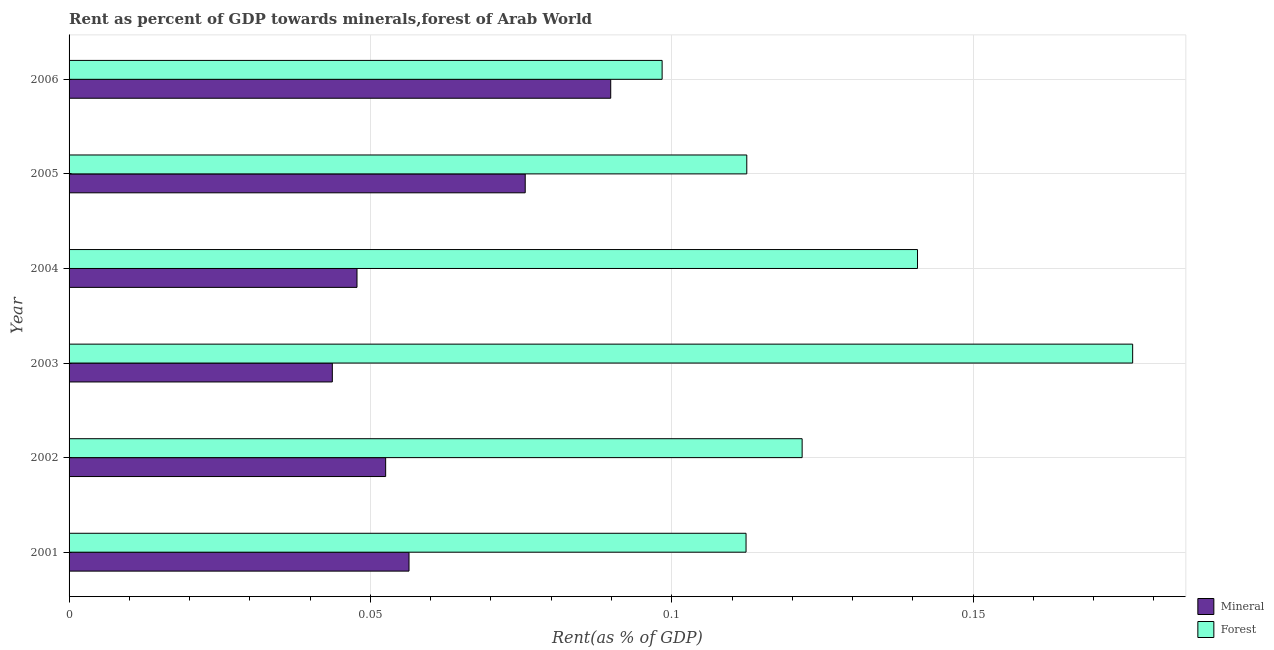How many different coloured bars are there?
Your answer should be compact. 2. Are the number of bars per tick equal to the number of legend labels?
Ensure brevity in your answer.  Yes. What is the label of the 6th group of bars from the top?
Offer a terse response. 2001. What is the forest rent in 2005?
Your response must be concise. 0.11. Across all years, what is the maximum mineral rent?
Your response must be concise. 0.09. Across all years, what is the minimum mineral rent?
Offer a very short reply. 0.04. In which year was the forest rent maximum?
Keep it short and to the point. 2003. What is the total mineral rent in the graph?
Your answer should be very brief. 0.37. What is the difference between the forest rent in 2002 and that in 2005?
Provide a succinct answer. 0.01. What is the difference between the mineral rent in 2004 and the forest rent in 2002?
Ensure brevity in your answer.  -0.07. What is the average mineral rent per year?
Keep it short and to the point. 0.06. In the year 2003, what is the difference between the mineral rent and forest rent?
Make the answer very short. -0.13. What is the ratio of the forest rent in 2001 to that in 2002?
Provide a succinct answer. 0.92. Is the difference between the mineral rent in 2001 and 2005 greater than the difference between the forest rent in 2001 and 2005?
Your response must be concise. No. What is the difference between the highest and the second highest forest rent?
Ensure brevity in your answer.  0.04. Is the sum of the forest rent in 2002 and 2005 greater than the maximum mineral rent across all years?
Ensure brevity in your answer.  Yes. What does the 2nd bar from the top in 2006 represents?
Offer a terse response. Mineral. What does the 1st bar from the bottom in 2006 represents?
Provide a succinct answer. Mineral. How many bars are there?
Your answer should be very brief. 12. Does the graph contain any zero values?
Provide a short and direct response. No. Where does the legend appear in the graph?
Your answer should be compact. Bottom right. How are the legend labels stacked?
Provide a short and direct response. Vertical. What is the title of the graph?
Ensure brevity in your answer.  Rent as percent of GDP towards minerals,forest of Arab World. Does "Frequency of shipment arrival" appear as one of the legend labels in the graph?
Keep it short and to the point. No. What is the label or title of the X-axis?
Provide a succinct answer. Rent(as % of GDP). What is the label or title of the Y-axis?
Keep it short and to the point. Year. What is the Rent(as % of GDP) in Mineral in 2001?
Provide a short and direct response. 0.06. What is the Rent(as % of GDP) in Forest in 2001?
Give a very brief answer. 0.11. What is the Rent(as % of GDP) of Mineral in 2002?
Offer a very short reply. 0.05. What is the Rent(as % of GDP) of Forest in 2002?
Offer a terse response. 0.12. What is the Rent(as % of GDP) of Mineral in 2003?
Make the answer very short. 0.04. What is the Rent(as % of GDP) in Forest in 2003?
Give a very brief answer. 0.18. What is the Rent(as % of GDP) of Mineral in 2004?
Ensure brevity in your answer.  0.05. What is the Rent(as % of GDP) of Forest in 2004?
Give a very brief answer. 0.14. What is the Rent(as % of GDP) in Mineral in 2005?
Offer a terse response. 0.08. What is the Rent(as % of GDP) in Forest in 2005?
Offer a very short reply. 0.11. What is the Rent(as % of GDP) in Mineral in 2006?
Keep it short and to the point. 0.09. What is the Rent(as % of GDP) of Forest in 2006?
Provide a short and direct response. 0.1. Across all years, what is the maximum Rent(as % of GDP) in Mineral?
Your answer should be compact. 0.09. Across all years, what is the maximum Rent(as % of GDP) of Forest?
Ensure brevity in your answer.  0.18. Across all years, what is the minimum Rent(as % of GDP) of Mineral?
Your answer should be very brief. 0.04. Across all years, what is the minimum Rent(as % of GDP) of Forest?
Make the answer very short. 0.1. What is the total Rent(as % of GDP) of Mineral in the graph?
Your response must be concise. 0.37. What is the total Rent(as % of GDP) in Forest in the graph?
Keep it short and to the point. 0.76. What is the difference between the Rent(as % of GDP) of Mineral in 2001 and that in 2002?
Make the answer very short. 0. What is the difference between the Rent(as % of GDP) of Forest in 2001 and that in 2002?
Your answer should be very brief. -0.01. What is the difference between the Rent(as % of GDP) in Mineral in 2001 and that in 2003?
Give a very brief answer. 0.01. What is the difference between the Rent(as % of GDP) in Forest in 2001 and that in 2003?
Offer a very short reply. -0.06. What is the difference between the Rent(as % of GDP) in Mineral in 2001 and that in 2004?
Give a very brief answer. 0.01. What is the difference between the Rent(as % of GDP) in Forest in 2001 and that in 2004?
Your answer should be very brief. -0.03. What is the difference between the Rent(as % of GDP) of Mineral in 2001 and that in 2005?
Provide a short and direct response. -0.02. What is the difference between the Rent(as % of GDP) in Forest in 2001 and that in 2005?
Ensure brevity in your answer.  -0. What is the difference between the Rent(as % of GDP) in Mineral in 2001 and that in 2006?
Your answer should be very brief. -0.03. What is the difference between the Rent(as % of GDP) of Forest in 2001 and that in 2006?
Your response must be concise. 0.01. What is the difference between the Rent(as % of GDP) of Mineral in 2002 and that in 2003?
Give a very brief answer. 0.01. What is the difference between the Rent(as % of GDP) in Forest in 2002 and that in 2003?
Offer a terse response. -0.05. What is the difference between the Rent(as % of GDP) in Mineral in 2002 and that in 2004?
Your answer should be compact. 0. What is the difference between the Rent(as % of GDP) in Forest in 2002 and that in 2004?
Keep it short and to the point. -0.02. What is the difference between the Rent(as % of GDP) in Mineral in 2002 and that in 2005?
Offer a terse response. -0.02. What is the difference between the Rent(as % of GDP) of Forest in 2002 and that in 2005?
Your response must be concise. 0.01. What is the difference between the Rent(as % of GDP) in Mineral in 2002 and that in 2006?
Offer a very short reply. -0.04. What is the difference between the Rent(as % of GDP) in Forest in 2002 and that in 2006?
Your answer should be compact. 0.02. What is the difference between the Rent(as % of GDP) of Mineral in 2003 and that in 2004?
Your response must be concise. -0. What is the difference between the Rent(as % of GDP) of Forest in 2003 and that in 2004?
Your response must be concise. 0.04. What is the difference between the Rent(as % of GDP) of Mineral in 2003 and that in 2005?
Provide a succinct answer. -0.03. What is the difference between the Rent(as % of GDP) of Forest in 2003 and that in 2005?
Offer a very short reply. 0.06. What is the difference between the Rent(as % of GDP) in Mineral in 2003 and that in 2006?
Provide a short and direct response. -0.05. What is the difference between the Rent(as % of GDP) of Forest in 2003 and that in 2006?
Keep it short and to the point. 0.08. What is the difference between the Rent(as % of GDP) of Mineral in 2004 and that in 2005?
Your answer should be compact. -0.03. What is the difference between the Rent(as % of GDP) of Forest in 2004 and that in 2005?
Your response must be concise. 0.03. What is the difference between the Rent(as % of GDP) of Mineral in 2004 and that in 2006?
Your answer should be compact. -0.04. What is the difference between the Rent(as % of GDP) of Forest in 2004 and that in 2006?
Your response must be concise. 0.04. What is the difference between the Rent(as % of GDP) of Mineral in 2005 and that in 2006?
Your answer should be compact. -0.01. What is the difference between the Rent(as % of GDP) in Forest in 2005 and that in 2006?
Keep it short and to the point. 0.01. What is the difference between the Rent(as % of GDP) of Mineral in 2001 and the Rent(as % of GDP) of Forest in 2002?
Provide a short and direct response. -0.07. What is the difference between the Rent(as % of GDP) of Mineral in 2001 and the Rent(as % of GDP) of Forest in 2003?
Make the answer very short. -0.12. What is the difference between the Rent(as % of GDP) of Mineral in 2001 and the Rent(as % of GDP) of Forest in 2004?
Give a very brief answer. -0.08. What is the difference between the Rent(as % of GDP) of Mineral in 2001 and the Rent(as % of GDP) of Forest in 2005?
Make the answer very short. -0.06. What is the difference between the Rent(as % of GDP) of Mineral in 2001 and the Rent(as % of GDP) of Forest in 2006?
Give a very brief answer. -0.04. What is the difference between the Rent(as % of GDP) in Mineral in 2002 and the Rent(as % of GDP) in Forest in 2003?
Offer a terse response. -0.12. What is the difference between the Rent(as % of GDP) of Mineral in 2002 and the Rent(as % of GDP) of Forest in 2004?
Give a very brief answer. -0.09. What is the difference between the Rent(as % of GDP) of Mineral in 2002 and the Rent(as % of GDP) of Forest in 2005?
Provide a short and direct response. -0.06. What is the difference between the Rent(as % of GDP) in Mineral in 2002 and the Rent(as % of GDP) in Forest in 2006?
Your answer should be very brief. -0.05. What is the difference between the Rent(as % of GDP) of Mineral in 2003 and the Rent(as % of GDP) of Forest in 2004?
Give a very brief answer. -0.1. What is the difference between the Rent(as % of GDP) of Mineral in 2003 and the Rent(as % of GDP) of Forest in 2005?
Your answer should be compact. -0.07. What is the difference between the Rent(as % of GDP) of Mineral in 2003 and the Rent(as % of GDP) of Forest in 2006?
Your answer should be compact. -0.05. What is the difference between the Rent(as % of GDP) in Mineral in 2004 and the Rent(as % of GDP) in Forest in 2005?
Make the answer very short. -0.06. What is the difference between the Rent(as % of GDP) of Mineral in 2004 and the Rent(as % of GDP) of Forest in 2006?
Offer a terse response. -0.05. What is the difference between the Rent(as % of GDP) in Mineral in 2005 and the Rent(as % of GDP) in Forest in 2006?
Offer a very short reply. -0.02. What is the average Rent(as % of GDP) in Mineral per year?
Ensure brevity in your answer.  0.06. What is the average Rent(as % of GDP) of Forest per year?
Offer a very short reply. 0.13. In the year 2001, what is the difference between the Rent(as % of GDP) in Mineral and Rent(as % of GDP) in Forest?
Offer a very short reply. -0.06. In the year 2002, what is the difference between the Rent(as % of GDP) of Mineral and Rent(as % of GDP) of Forest?
Your answer should be very brief. -0.07. In the year 2003, what is the difference between the Rent(as % of GDP) of Mineral and Rent(as % of GDP) of Forest?
Provide a succinct answer. -0.13. In the year 2004, what is the difference between the Rent(as % of GDP) in Mineral and Rent(as % of GDP) in Forest?
Provide a succinct answer. -0.09. In the year 2005, what is the difference between the Rent(as % of GDP) of Mineral and Rent(as % of GDP) of Forest?
Your response must be concise. -0.04. In the year 2006, what is the difference between the Rent(as % of GDP) in Mineral and Rent(as % of GDP) in Forest?
Ensure brevity in your answer.  -0.01. What is the ratio of the Rent(as % of GDP) of Mineral in 2001 to that in 2002?
Your response must be concise. 1.07. What is the ratio of the Rent(as % of GDP) in Forest in 2001 to that in 2002?
Offer a terse response. 0.92. What is the ratio of the Rent(as % of GDP) in Mineral in 2001 to that in 2003?
Offer a very short reply. 1.29. What is the ratio of the Rent(as % of GDP) of Forest in 2001 to that in 2003?
Your answer should be compact. 0.64. What is the ratio of the Rent(as % of GDP) in Mineral in 2001 to that in 2004?
Make the answer very short. 1.18. What is the ratio of the Rent(as % of GDP) in Forest in 2001 to that in 2004?
Provide a short and direct response. 0.8. What is the ratio of the Rent(as % of GDP) of Mineral in 2001 to that in 2005?
Your response must be concise. 0.75. What is the ratio of the Rent(as % of GDP) in Forest in 2001 to that in 2005?
Ensure brevity in your answer.  1. What is the ratio of the Rent(as % of GDP) of Mineral in 2001 to that in 2006?
Your response must be concise. 0.63. What is the ratio of the Rent(as % of GDP) in Forest in 2001 to that in 2006?
Provide a short and direct response. 1.14. What is the ratio of the Rent(as % of GDP) of Mineral in 2002 to that in 2003?
Provide a short and direct response. 1.2. What is the ratio of the Rent(as % of GDP) of Forest in 2002 to that in 2003?
Offer a terse response. 0.69. What is the ratio of the Rent(as % of GDP) in Mineral in 2002 to that in 2004?
Your answer should be compact. 1.1. What is the ratio of the Rent(as % of GDP) in Forest in 2002 to that in 2004?
Ensure brevity in your answer.  0.86. What is the ratio of the Rent(as % of GDP) in Mineral in 2002 to that in 2005?
Offer a terse response. 0.69. What is the ratio of the Rent(as % of GDP) in Forest in 2002 to that in 2005?
Provide a short and direct response. 1.08. What is the ratio of the Rent(as % of GDP) in Mineral in 2002 to that in 2006?
Offer a terse response. 0.58. What is the ratio of the Rent(as % of GDP) in Forest in 2002 to that in 2006?
Provide a short and direct response. 1.24. What is the ratio of the Rent(as % of GDP) of Mineral in 2003 to that in 2004?
Your answer should be very brief. 0.91. What is the ratio of the Rent(as % of GDP) of Forest in 2003 to that in 2004?
Provide a short and direct response. 1.25. What is the ratio of the Rent(as % of GDP) in Mineral in 2003 to that in 2005?
Provide a succinct answer. 0.58. What is the ratio of the Rent(as % of GDP) of Forest in 2003 to that in 2005?
Your response must be concise. 1.57. What is the ratio of the Rent(as % of GDP) of Mineral in 2003 to that in 2006?
Provide a succinct answer. 0.49. What is the ratio of the Rent(as % of GDP) of Forest in 2003 to that in 2006?
Keep it short and to the point. 1.79. What is the ratio of the Rent(as % of GDP) of Mineral in 2004 to that in 2005?
Your answer should be compact. 0.63. What is the ratio of the Rent(as % of GDP) in Forest in 2004 to that in 2005?
Keep it short and to the point. 1.25. What is the ratio of the Rent(as % of GDP) of Mineral in 2004 to that in 2006?
Offer a terse response. 0.53. What is the ratio of the Rent(as % of GDP) of Forest in 2004 to that in 2006?
Offer a very short reply. 1.43. What is the ratio of the Rent(as % of GDP) of Mineral in 2005 to that in 2006?
Keep it short and to the point. 0.84. What is the ratio of the Rent(as % of GDP) in Forest in 2005 to that in 2006?
Make the answer very short. 1.14. What is the difference between the highest and the second highest Rent(as % of GDP) of Mineral?
Keep it short and to the point. 0.01. What is the difference between the highest and the second highest Rent(as % of GDP) of Forest?
Give a very brief answer. 0.04. What is the difference between the highest and the lowest Rent(as % of GDP) in Mineral?
Provide a short and direct response. 0.05. What is the difference between the highest and the lowest Rent(as % of GDP) of Forest?
Offer a very short reply. 0.08. 